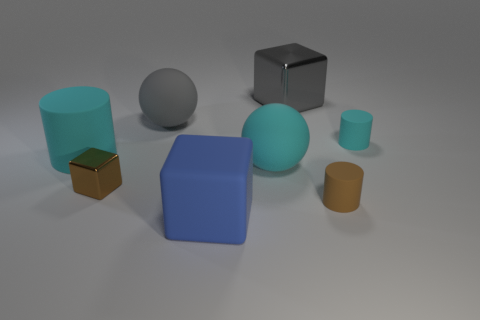Which of these objects is the lightest, and how can you tell? Without knowing the exact materials, it's a bit speculative, but based on common material densities, the small yellow object in the front right may be the lightest, as it appears smaller in volume and could be made of a lighter plastic or similar material. 